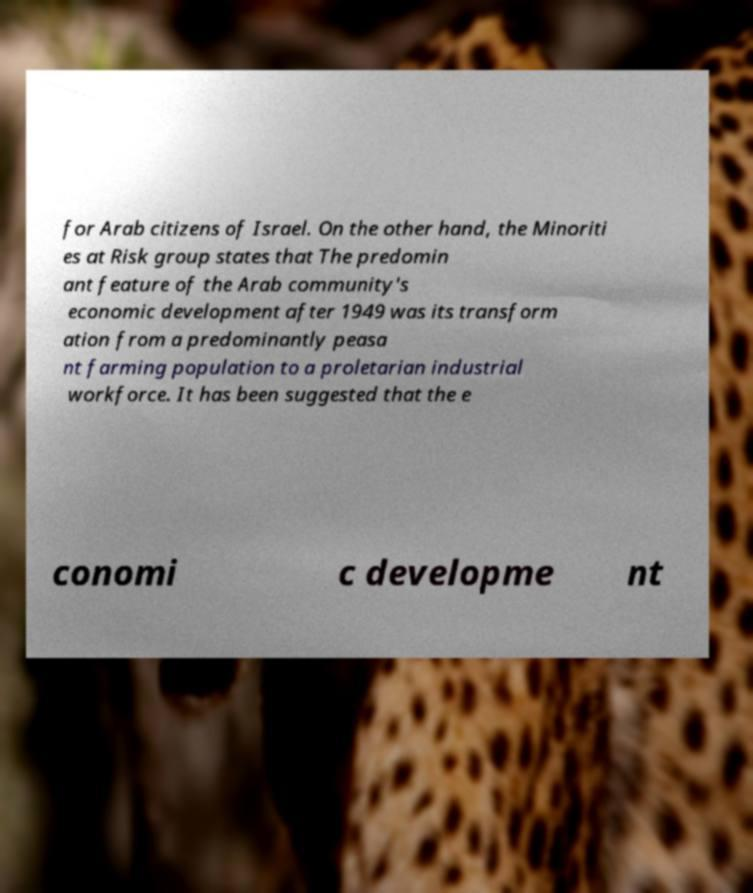Could you extract and type out the text from this image? for Arab citizens of Israel. On the other hand, the Minoriti es at Risk group states that The predomin ant feature of the Arab community's economic development after 1949 was its transform ation from a predominantly peasa nt farming population to a proletarian industrial workforce. It has been suggested that the e conomi c developme nt 